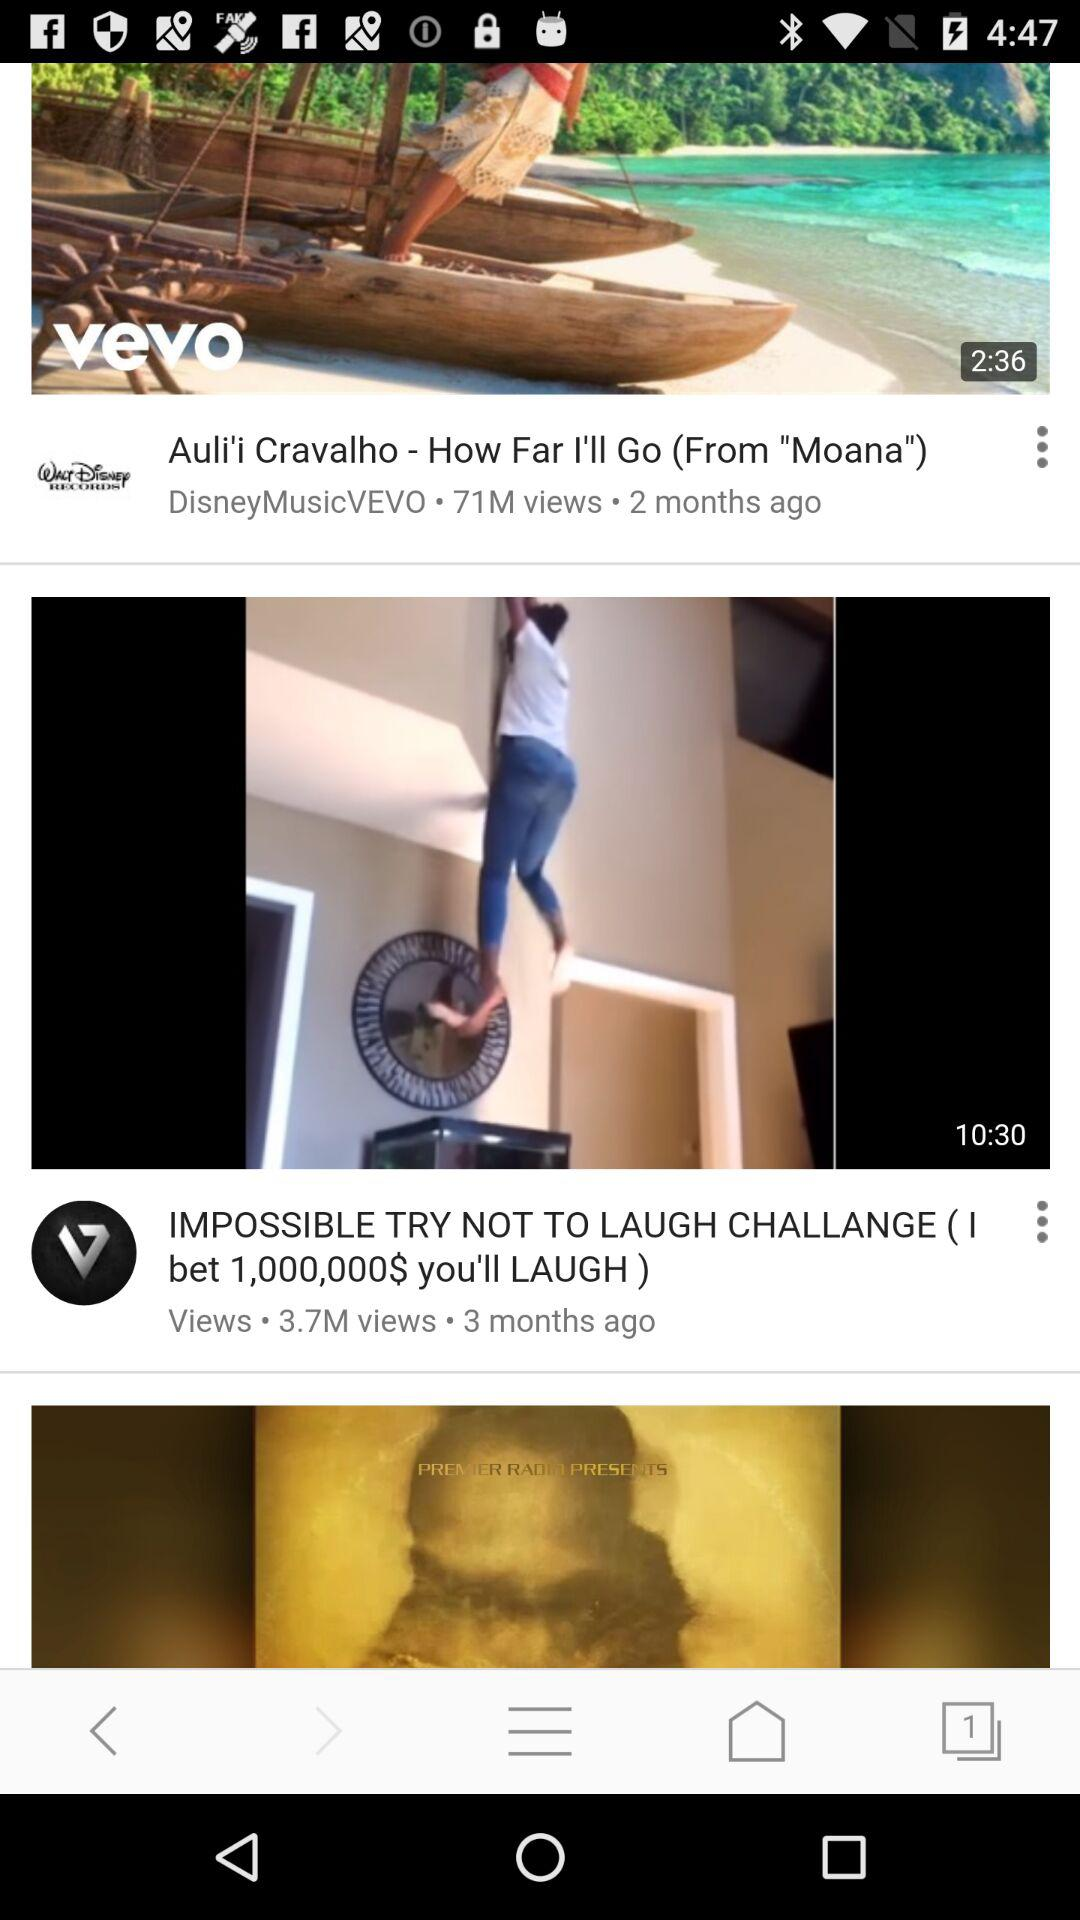How many views are there on "Auli'i Cravalho - How Far I'll Go (From "Moana")"? There are 71 million views on "Auli'i Cravalho - How Far I'll Go (From "Moana")". 